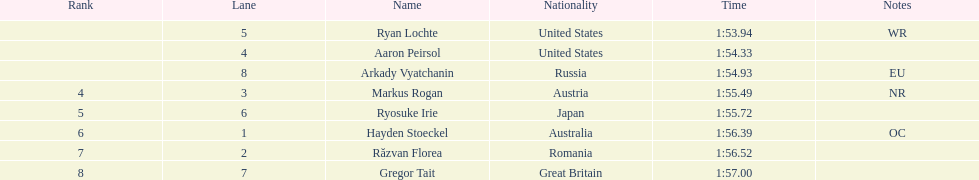Which adversary was the last to finish? Gregor Tait. 